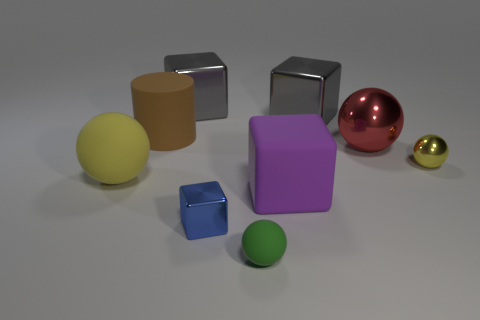Is the number of large brown matte cylinders that are right of the big brown rubber object the same as the number of gray objects that are left of the green sphere?
Your answer should be compact. No. Are there any tiny purple rubber things?
Your answer should be compact. No. The blue shiny thing that is the same shape as the big purple rubber object is what size?
Make the answer very short. Small. How big is the rubber thing behind the big yellow rubber object?
Ensure brevity in your answer.  Large. Are there more yellow spheres right of the large matte sphere than brown metallic blocks?
Give a very brief answer. Yes. What is the shape of the tiny matte object?
Ensure brevity in your answer.  Sphere. There is a small thing that is to the left of the green matte object; is its color the same as the ball that is in front of the blue cube?
Offer a very short reply. No. Is the big yellow matte object the same shape as the tiny matte object?
Provide a short and direct response. Yes. Are there any other things that are the same shape as the yellow shiny object?
Give a very brief answer. Yes. Does the yellow ball that is on the left side of the green ball have the same material as the big red sphere?
Offer a very short reply. No. 